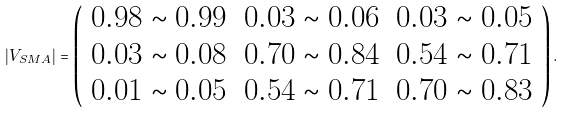Convert formula to latex. <formula><loc_0><loc_0><loc_500><loc_500>| V _ { S M A } | = \left ( \begin{array} { c c c } 0 . 9 8 \sim 0 . 9 9 & 0 . 0 3 \sim 0 . 0 6 & 0 . 0 3 \sim 0 . 0 5 \\ 0 . 0 3 \sim 0 . 0 8 & 0 . 7 0 \sim 0 . 8 4 & 0 . 5 4 \sim 0 . 7 1 \\ 0 . 0 1 \sim 0 . 0 5 & 0 . 5 4 \sim 0 . 7 1 & 0 . 7 0 \sim 0 . 8 3 \\ \end{array} \right ) .</formula> 